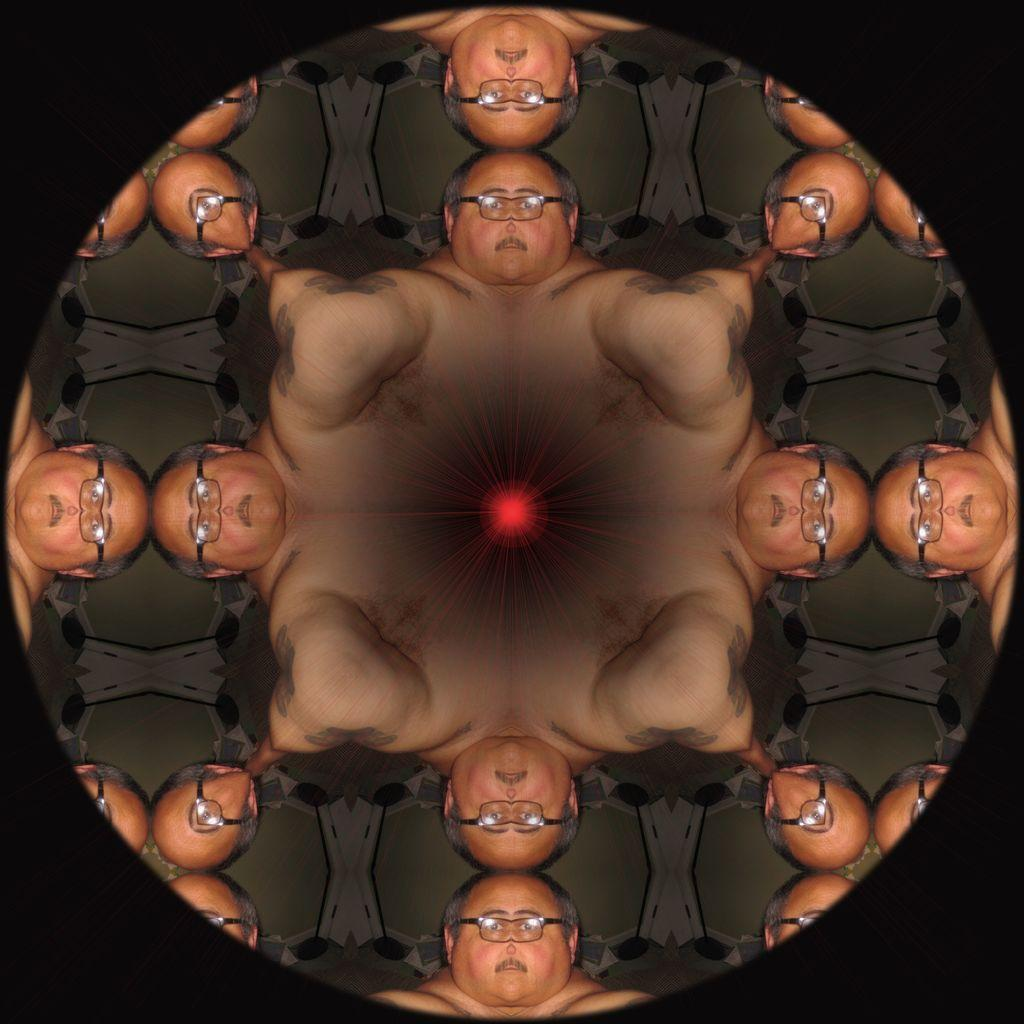What type of image is being described? The image is an edited picture. What is the main subject of the edited picture? The edited picture contains a person's face. What accessory is the person's face wearing? The person's face is wearing glasses. How many times is the person's face with glasses shown in the image? The person's face with glasses is shown multiple times in the image. What type of fruit is being used as a door in the image? There is no fruit or door present in the image; it only contains a person's face with glasses shown multiple times. 